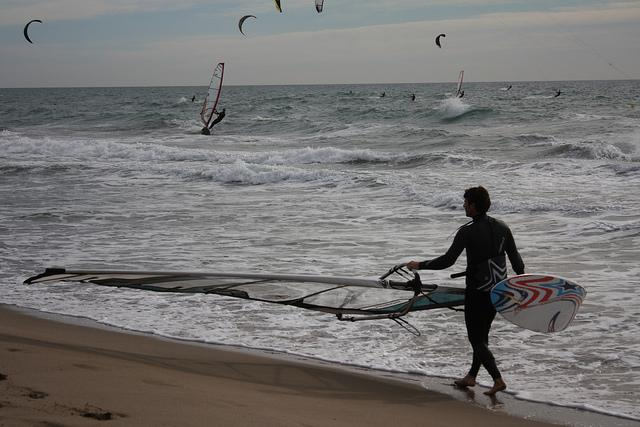What is the parachute called in paragliding?

Choices:
A) canopy
B) wing
C) balloon
D) parachute canopy 